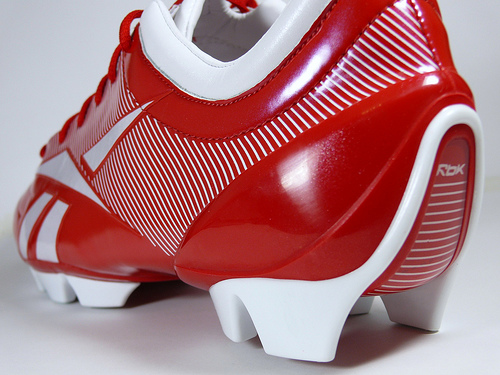<image>
Can you confirm if the shoe is on the floor? Yes. Looking at the image, I can see the shoe is positioned on top of the floor, with the floor providing support. 